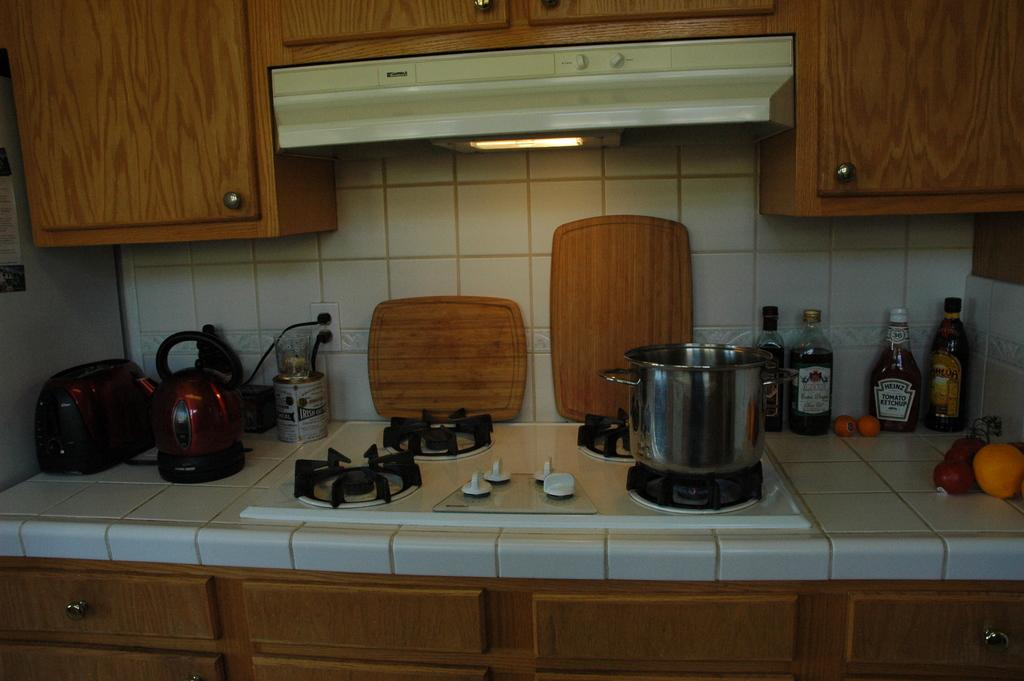<image>
Render a clear and concise summary of the photo. A stovetop on a counter with a metal pot and cutting boards with bottles of condiments like Heinz Tomato ketchup and others. 